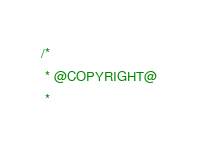Convert code to text. <code><loc_0><loc_0><loc_500><loc_500><_C++_>/*
 * @COPYRIGHT@
 *</code> 